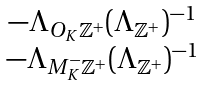Convert formula to latex. <formula><loc_0><loc_0><loc_500><loc_500>\begin{matrix} - \Lambda _ { O _ { K } \mathbb { Z } ^ { + } } ( \Lambda _ { \mathbb { Z } ^ { + } } ) ^ { - 1 } \\ - \Lambda _ { M _ { K } ^ { - } \mathbb { Z } ^ { + } } ( \Lambda _ { \mathbb { Z } ^ { + } } ) ^ { - 1 } \end{matrix}</formula> 